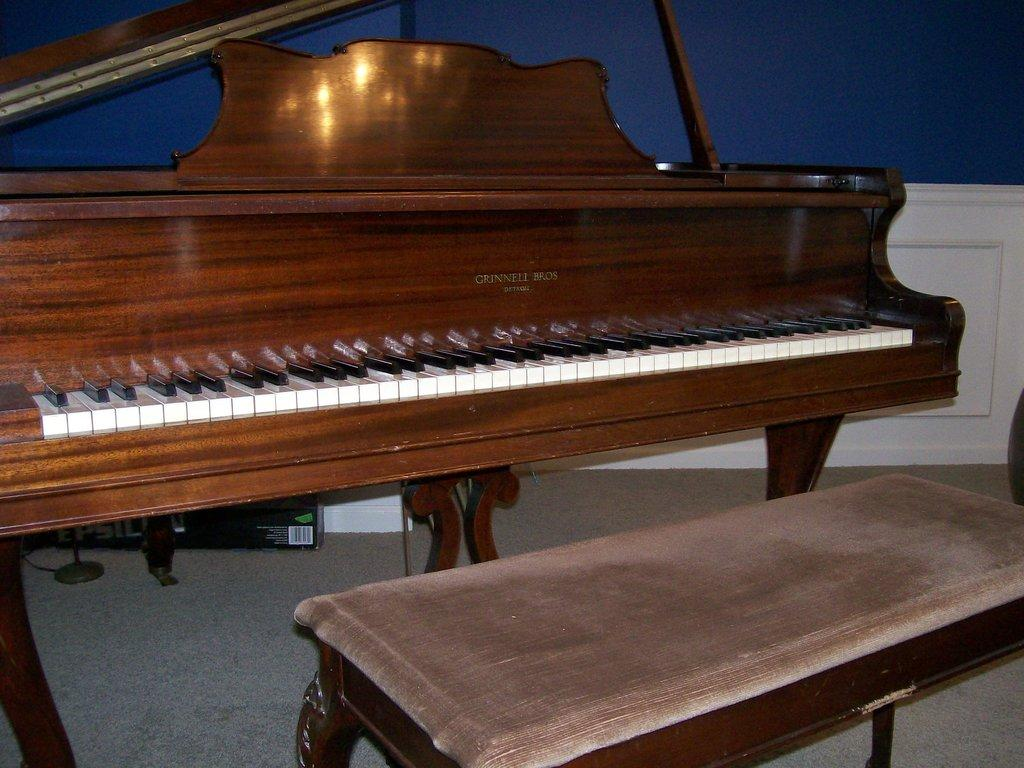What musical instrument is present in the image? There is a piano in the image. What type of seat is in the image? There is a wooden seat in the image. What is the purpose of the wooden seat? The wooden seat is for sitting and playing the piano. What type of bike is visible in the image? There is no bike present in the image; it only features a piano and a wooden seat. 